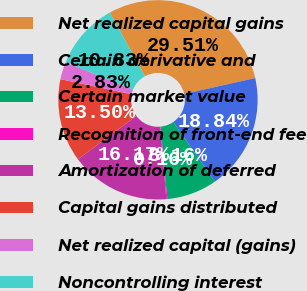Convert chart. <chart><loc_0><loc_0><loc_500><loc_500><pie_chart><fcel>Net realized capital gains<fcel>Certain derivative and<fcel>Certain market value<fcel>Recognition of front-end fee<fcel>Amortization of deferred<fcel>Capital gains distributed<fcel>Net realized capital (gains)<fcel>Noncontrolling interest<nl><fcel>29.51%<fcel>18.84%<fcel>8.16%<fcel>0.16%<fcel>16.17%<fcel>13.5%<fcel>2.83%<fcel>10.83%<nl></chart> 